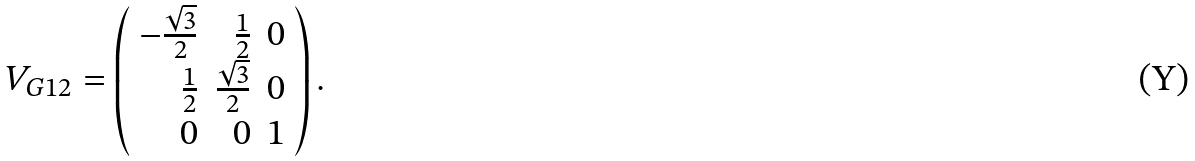<formula> <loc_0><loc_0><loc_500><loc_500>V _ { G 1 2 } = \left ( \begin{array} { r r r } - { \frac { \sqrt { 3 } } { 2 } } & { \frac { 1 } { 2 } } & 0 \\ { \frac { 1 } { 2 } } & { \frac { \sqrt { 3 } } { 2 } } & { 0 } \\ { 0 } & 0 & { 1 } \end{array} \right ) .</formula> 